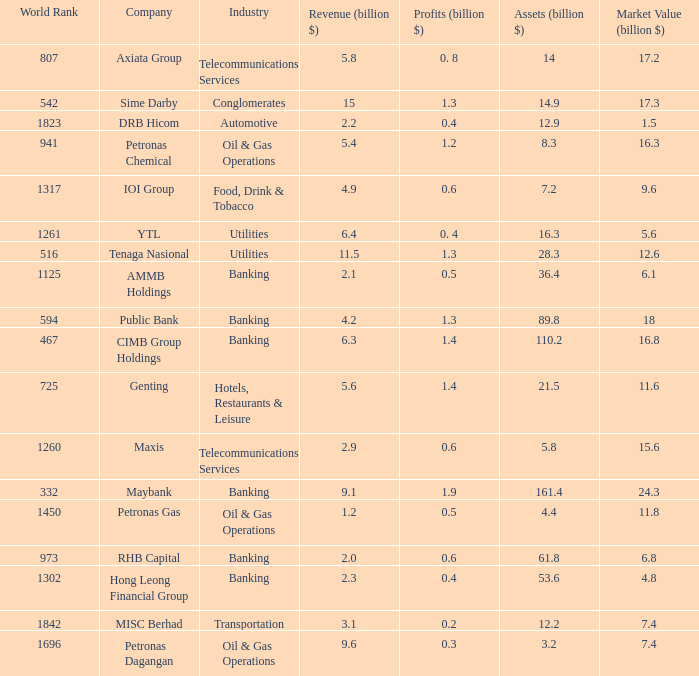Name the market value for rhb capital 6.8. 